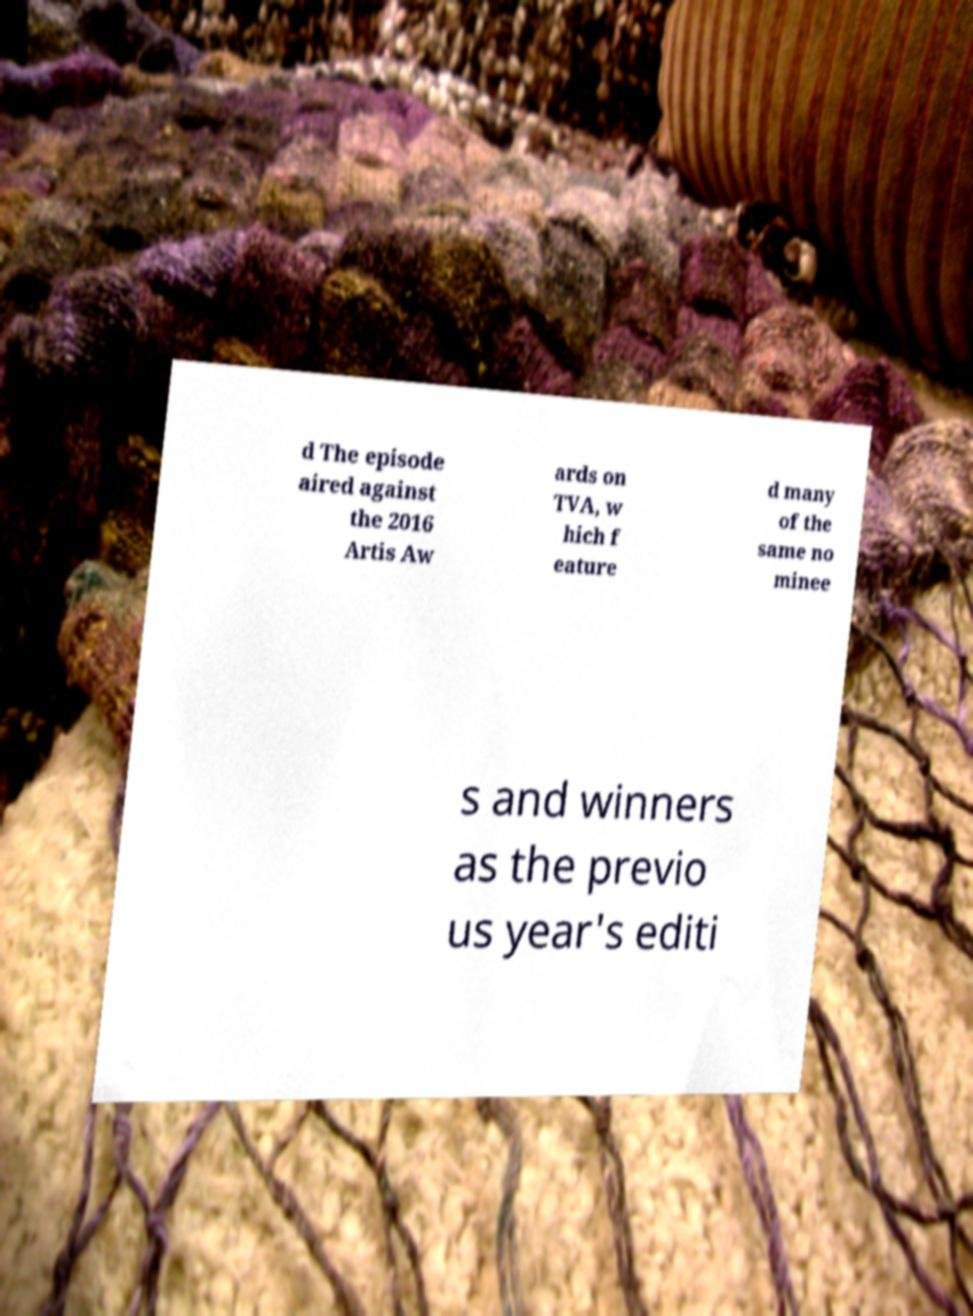I need the written content from this picture converted into text. Can you do that? d The episode aired against the 2016 Artis Aw ards on TVA, w hich f eature d many of the same no minee s and winners as the previo us year's editi 